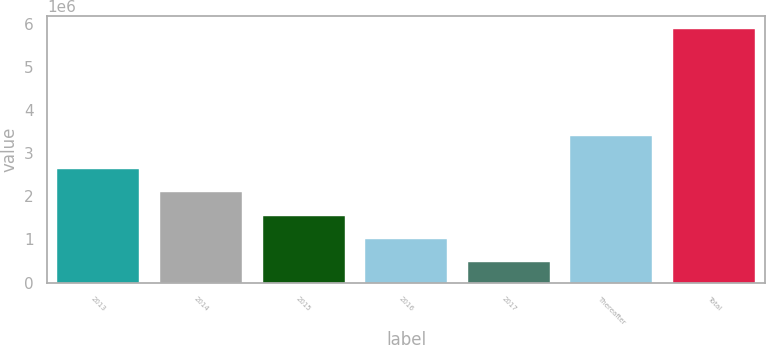Convert chart. <chart><loc_0><loc_0><loc_500><loc_500><bar_chart><fcel>2013<fcel>2014<fcel>2015<fcel>2016<fcel>2017<fcel>Thereafter<fcel>Total<nl><fcel>2.63237e+06<fcel>2.09052e+06<fcel>1.54868e+06<fcel>1.00683e+06<fcel>464982<fcel>3.39912e+06<fcel>5.88346e+06<nl></chart> 